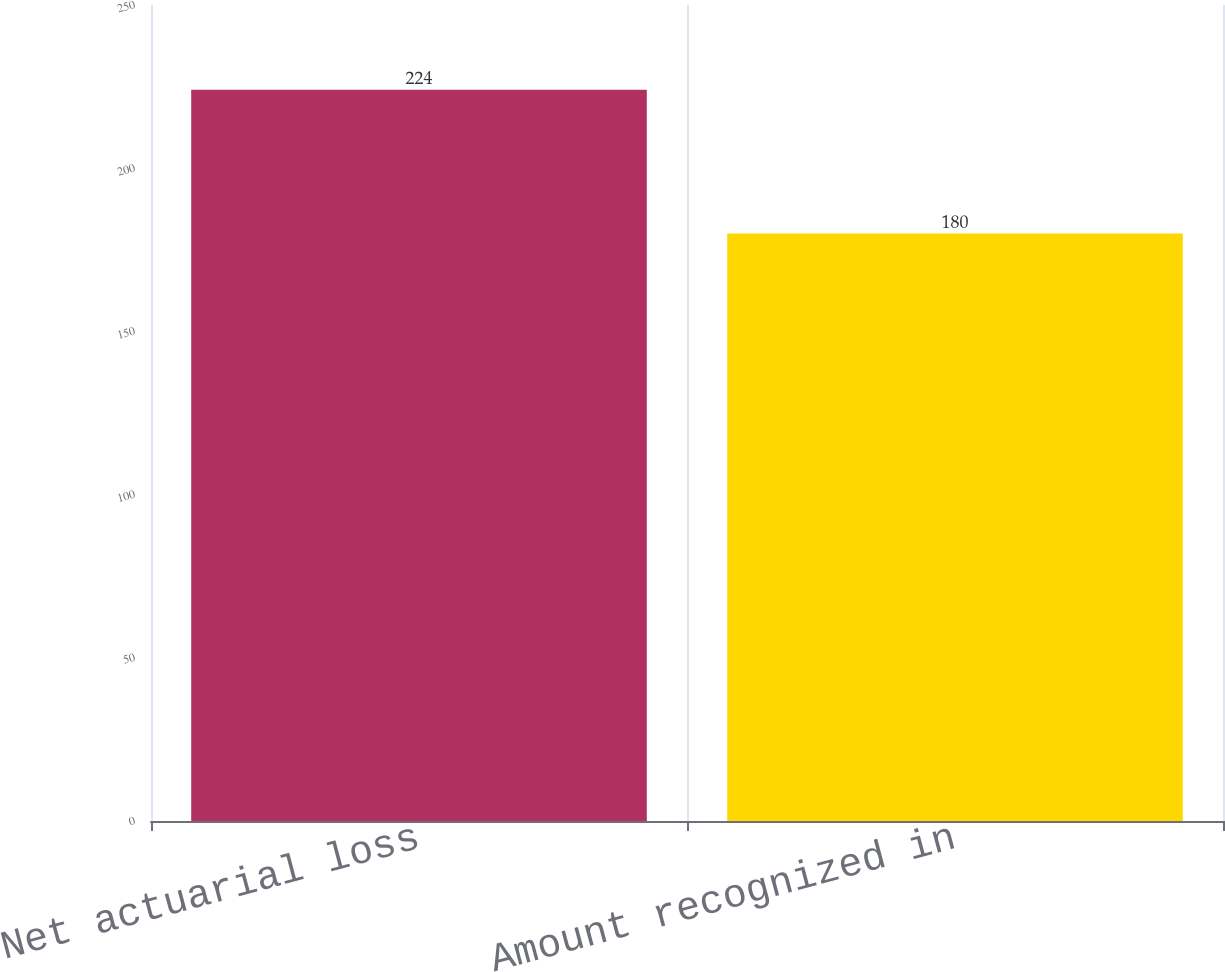<chart> <loc_0><loc_0><loc_500><loc_500><bar_chart><fcel>Net actuarial loss<fcel>Amount recognized in<nl><fcel>224<fcel>180<nl></chart> 